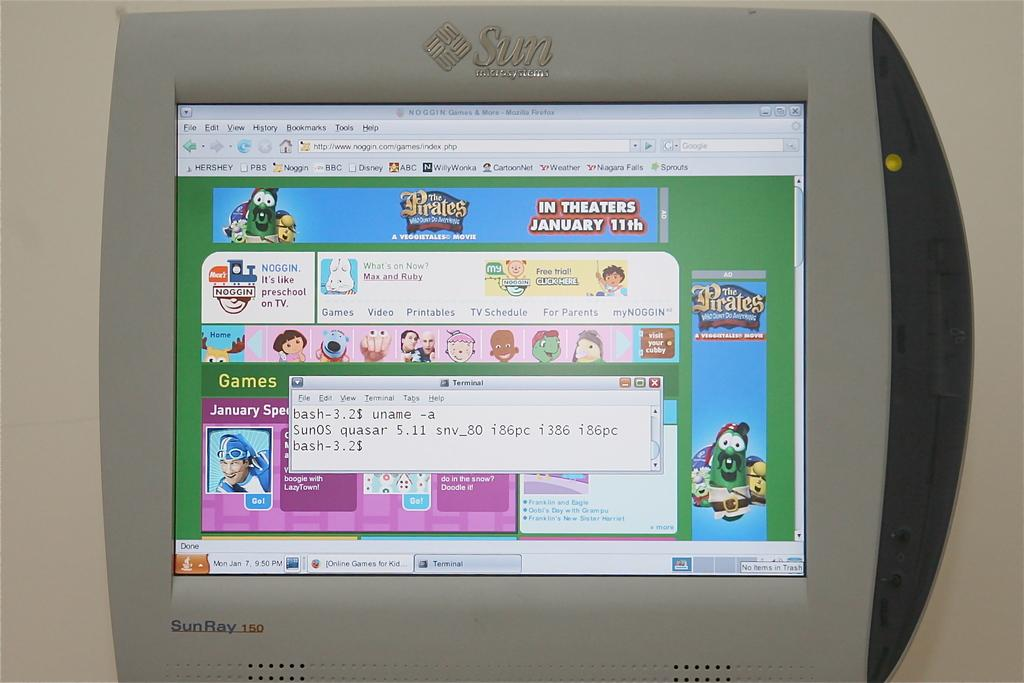<image>
Provide a brief description of the given image. On a Sun monitor a website advertisement is for The Pirates, in theaters January 11th. 